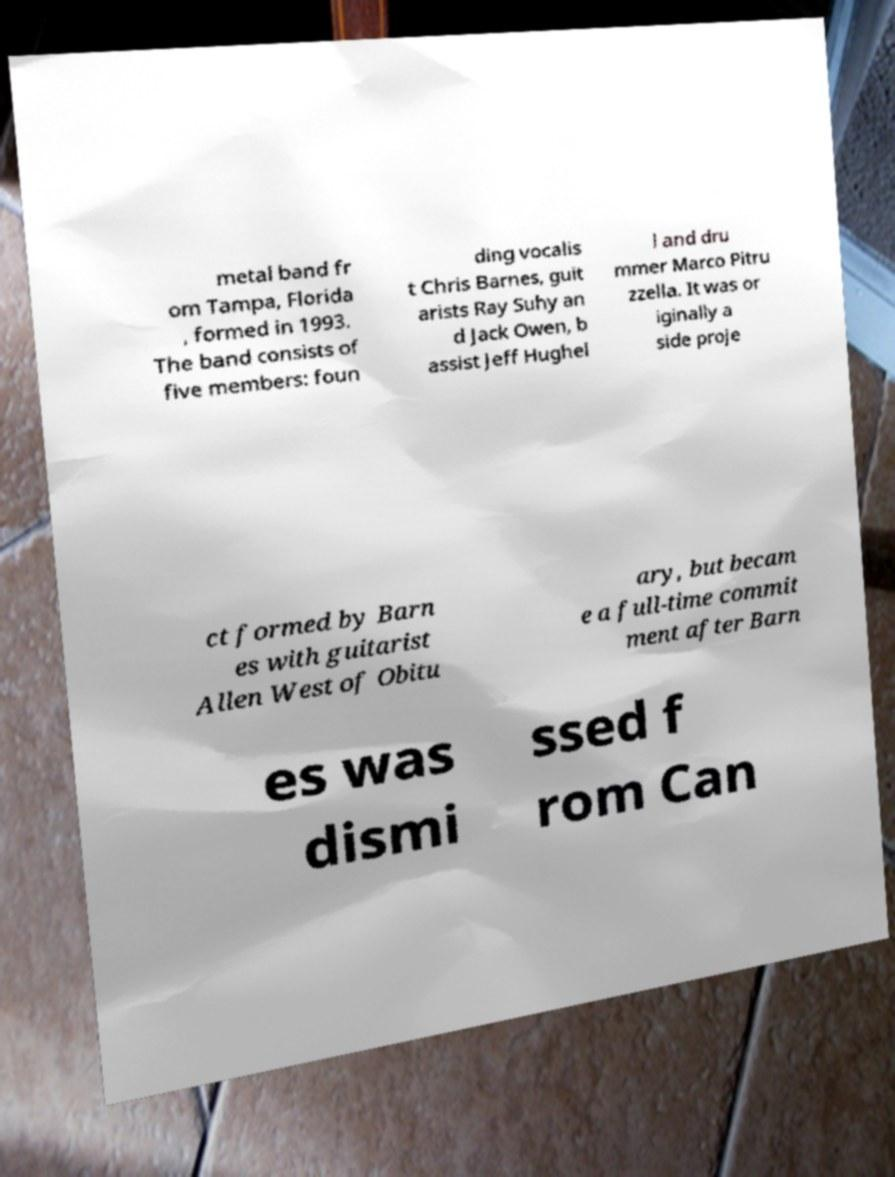Could you assist in decoding the text presented in this image and type it out clearly? metal band fr om Tampa, Florida , formed in 1993. The band consists of five members: foun ding vocalis t Chris Barnes, guit arists Ray Suhy an d Jack Owen, b assist Jeff Hughel l and dru mmer Marco Pitru zzella. It was or iginally a side proje ct formed by Barn es with guitarist Allen West of Obitu ary, but becam e a full-time commit ment after Barn es was dismi ssed f rom Can 